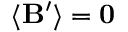Convert formula to latex. <formula><loc_0><loc_0><loc_500><loc_500>\langle B ^ { \prime } \rangle = 0</formula> 